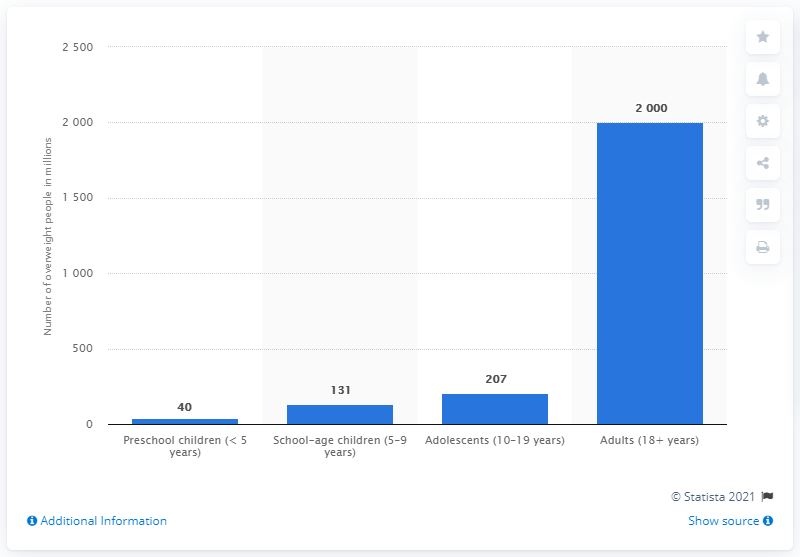Indicate a few pertinent items in this graphic. As of 2019, it is estimated that 207 adolescents were overweight. As of 2019, it is estimated that there were approximately 2 billion adults worldwide who were overweight. As of 2019, it is estimated that there were 207 adolescents who were overweight. 